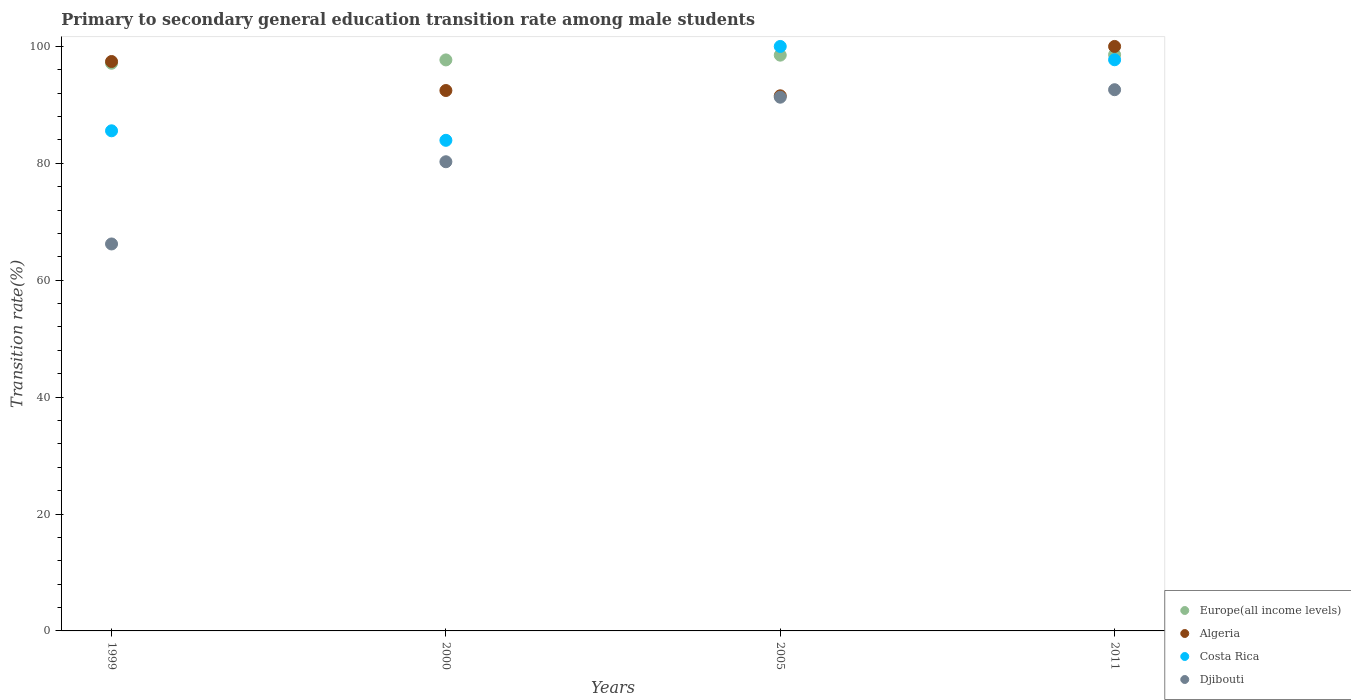What is the transition rate in Costa Rica in 2000?
Provide a succinct answer. 83.94. Across all years, what is the maximum transition rate in Algeria?
Offer a terse response. 100. Across all years, what is the minimum transition rate in Europe(all income levels)?
Your response must be concise. 97.13. What is the total transition rate in Algeria in the graph?
Ensure brevity in your answer.  381.44. What is the difference between the transition rate in Costa Rica in 1999 and that in 2011?
Make the answer very short. -12.15. What is the difference between the transition rate in Djibouti in 2011 and the transition rate in Costa Rica in 2000?
Offer a very short reply. 8.66. What is the average transition rate in Djibouti per year?
Your answer should be compact. 82.6. In the year 2005, what is the difference between the transition rate in Algeria and transition rate in Costa Rica?
Provide a succinct answer. -8.44. In how many years, is the transition rate in Algeria greater than 76 %?
Your answer should be very brief. 4. What is the ratio of the transition rate in Costa Rica in 2005 to that in 2011?
Your answer should be very brief. 1.02. What is the difference between the highest and the second highest transition rate in Costa Rica?
Your answer should be compact. 2.28. What is the difference between the highest and the lowest transition rate in Djibouti?
Give a very brief answer. 26.39. Is the sum of the transition rate in Costa Rica in 2005 and 2011 greater than the maximum transition rate in Algeria across all years?
Give a very brief answer. Yes. Is it the case that in every year, the sum of the transition rate in Costa Rica and transition rate in Algeria  is greater than the sum of transition rate in Europe(all income levels) and transition rate in Djibouti?
Ensure brevity in your answer.  No. Is it the case that in every year, the sum of the transition rate in Algeria and transition rate in Costa Rica  is greater than the transition rate in Djibouti?
Your answer should be very brief. Yes. Are the values on the major ticks of Y-axis written in scientific E-notation?
Provide a succinct answer. No. Does the graph contain any zero values?
Make the answer very short. No. Where does the legend appear in the graph?
Your answer should be very brief. Bottom right. What is the title of the graph?
Offer a very short reply. Primary to secondary general education transition rate among male students. What is the label or title of the Y-axis?
Your answer should be compact. Transition rate(%). What is the Transition rate(%) of Europe(all income levels) in 1999?
Your answer should be very brief. 97.13. What is the Transition rate(%) of Algeria in 1999?
Your answer should be very brief. 97.42. What is the Transition rate(%) in Costa Rica in 1999?
Make the answer very short. 85.57. What is the Transition rate(%) in Djibouti in 1999?
Your response must be concise. 66.21. What is the Transition rate(%) in Europe(all income levels) in 2000?
Your answer should be compact. 97.7. What is the Transition rate(%) in Algeria in 2000?
Keep it short and to the point. 92.46. What is the Transition rate(%) in Costa Rica in 2000?
Offer a terse response. 83.94. What is the Transition rate(%) in Djibouti in 2000?
Your answer should be very brief. 80.27. What is the Transition rate(%) in Europe(all income levels) in 2005?
Make the answer very short. 98.51. What is the Transition rate(%) of Algeria in 2005?
Offer a terse response. 91.56. What is the Transition rate(%) of Costa Rica in 2005?
Provide a succinct answer. 100. What is the Transition rate(%) in Djibouti in 2005?
Make the answer very short. 91.32. What is the Transition rate(%) of Europe(all income levels) in 2011?
Your answer should be compact. 98.59. What is the Transition rate(%) in Algeria in 2011?
Make the answer very short. 100. What is the Transition rate(%) of Costa Rica in 2011?
Offer a very short reply. 97.72. What is the Transition rate(%) of Djibouti in 2011?
Keep it short and to the point. 92.6. Across all years, what is the maximum Transition rate(%) in Europe(all income levels)?
Your answer should be compact. 98.59. Across all years, what is the maximum Transition rate(%) in Costa Rica?
Make the answer very short. 100. Across all years, what is the maximum Transition rate(%) in Djibouti?
Offer a terse response. 92.6. Across all years, what is the minimum Transition rate(%) in Europe(all income levels)?
Offer a very short reply. 97.13. Across all years, what is the minimum Transition rate(%) of Algeria?
Give a very brief answer. 91.56. Across all years, what is the minimum Transition rate(%) in Costa Rica?
Make the answer very short. 83.94. Across all years, what is the minimum Transition rate(%) in Djibouti?
Offer a terse response. 66.21. What is the total Transition rate(%) of Europe(all income levels) in the graph?
Provide a short and direct response. 391.92. What is the total Transition rate(%) of Algeria in the graph?
Your response must be concise. 381.44. What is the total Transition rate(%) of Costa Rica in the graph?
Make the answer very short. 367.23. What is the total Transition rate(%) of Djibouti in the graph?
Your answer should be very brief. 330.4. What is the difference between the Transition rate(%) of Europe(all income levels) in 1999 and that in 2000?
Your response must be concise. -0.57. What is the difference between the Transition rate(%) in Algeria in 1999 and that in 2000?
Your answer should be very brief. 4.96. What is the difference between the Transition rate(%) of Costa Rica in 1999 and that in 2000?
Your answer should be compact. 1.63. What is the difference between the Transition rate(%) in Djibouti in 1999 and that in 2000?
Give a very brief answer. -14.07. What is the difference between the Transition rate(%) of Europe(all income levels) in 1999 and that in 2005?
Provide a short and direct response. -1.39. What is the difference between the Transition rate(%) in Algeria in 1999 and that in 2005?
Your answer should be compact. 5.87. What is the difference between the Transition rate(%) in Costa Rica in 1999 and that in 2005?
Your answer should be compact. -14.43. What is the difference between the Transition rate(%) of Djibouti in 1999 and that in 2005?
Your answer should be very brief. -25.11. What is the difference between the Transition rate(%) in Europe(all income levels) in 1999 and that in 2011?
Your answer should be compact. -1.46. What is the difference between the Transition rate(%) of Algeria in 1999 and that in 2011?
Offer a terse response. -2.58. What is the difference between the Transition rate(%) of Costa Rica in 1999 and that in 2011?
Your answer should be very brief. -12.15. What is the difference between the Transition rate(%) in Djibouti in 1999 and that in 2011?
Offer a very short reply. -26.39. What is the difference between the Transition rate(%) in Europe(all income levels) in 2000 and that in 2005?
Offer a very short reply. -0.81. What is the difference between the Transition rate(%) in Algeria in 2000 and that in 2005?
Provide a succinct answer. 0.91. What is the difference between the Transition rate(%) in Costa Rica in 2000 and that in 2005?
Your answer should be compact. -16.06. What is the difference between the Transition rate(%) of Djibouti in 2000 and that in 2005?
Your answer should be compact. -11.04. What is the difference between the Transition rate(%) in Europe(all income levels) in 2000 and that in 2011?
Your answer should be very brief. -0.89. What is the difference between the Transition rate(%) in Algeria in 2000 and that in 2011?
Provide a short and direct response. -7.54. What is the difference between the Transition rate(%) in Costa Rica in 2000 and that in 2011?
Offer a very short reply. -13.78. What is the difference between the Transition rate(%) of Djibouti in 2000 and that in 2011?
Keep it short and to the point. -12.32. What is the difference between the Transition rate(%) of Europe(all income levels) in 2005 and that in 2011?
Offer a very short reply. -0.08. What is the difference between the Transition rate(%) in Algeria in 2005 and that in 2011?
Offer a terse response. -8.44. What is the difference between the Transition rate(%) in Costa Rica in 2005 and that in 2011?
Ensure brevity in your answer.  2.28. What is the difference between the Transition rate(%) in Djibouti in 2005 and that in 2011?
Provide a short and direct response. -1.28. What is the difference between the Transition rate(%) in Europe(all income levels) in 1999 and the Transition rate(%) in Algeria in 2000?
Your answer should be very brief. 4.66. What is the difference between the Transition rate(%) in Europe(all income levels) in 1999 and the Transition rate(%) in Costa Rica in 2000?
Your response must be concise. 13.19. What is the difference between the Transition rate(%) of Europe(all income levels) in 1999 and the Transition rate(%) of Djibouti in 2000?
Your response must be concise. 16.85. What is the difference between the Transition rate(%) in Algeria in 1999 and the Transition rate(%) in Costa Rica in 2000?
Your answer should be compact. 13.49. What is the difference between the Transition rate(%) in Algeria in 1999 and the Transition rate(%) in Djibouti in 2000?
Make the answer very short. 17.15. What is the difference between the Transition rate(%) in Costa Rica in 1999 and the Transition rate(%) in Djibouti in 2000?
Offer a very short reply. 5.3. What is the difference between the Transition rate(%) in Europe(all income levels) in 1999 and the Transition rate(%) in Algeria in 2005?
Ensure brevity in your answer.  5.57. What is the difference between the Transition rate(%) in Europe(all income levels) in 1999 and the Transition rate(%) in Costa Rica in 2005?
Make the answer very short. -2.87. What is the difference between the Transition rate(%) in Europe(all income levels) in 1999 and the Transition rate(%) in Djibouti in 2005?
Make the answer very short. 5.81. What is the difference between the Transition rate(%) in Algeria in 1999 and the Transition rate(%) in Costa Rica in 2005?
Offer a terse response. -2.58. What is the difference between the Transition rate(%) in Algeria in 1999 and the Transition rate(%) in Djibouti in 2005?
Offer a terse response. 6.11. What is the difference between the Transition rate(%) of Costa Rica in 1999 and the Transition rate(%) of Djibouti in 2005?
Your answer should be compact. -5.75. What is the difference between the Transition rate(%) in Europe(all income levels) in 1999 and the Transition rate(%) in Algeria in 2011?
Ensure brevity in your answer.  -2.87. What is the difference between the Transition rate(%) of Europe(all income levels) in 1999 and the Transition rate(%) of Costa Rica in 2011?
Provide a succinct answer. -0.6. What is the difference between the Transition rate(%) in Europe(all income levels) in 1999 and the Transition rate(%) in Djibouti in 2011?
Your answer should be compact. 4.53. What is the difference between the Transition rate(%) in Algeria in 1999 and the Transition rate(%) in Costa Rica in 2011?
Your answer should be very brief. -0.3. What is the difference between the Transition rate(%) in Algeria in 1999 and the Transition rate(%) in Djibouti in 2011?
Make the answer very short. 4.83. What is the difference between the Transition rate(%) of Costa Rica in 1999 and the Transition rate(%) of Djibouti in 2011?
Offer a terse response. -7.03. What is the difference between the Transition rate(%) in Europe(all income levels) in 2000 and the Transition rate(%) in Algeria in 2005?
Provide a short and direct response. 6.14. What is the difference between the Transition rate(%) of Europe(all income levels) in 2000 and the Transition rate(%) of Costa Rica in 2005?
Offer a terse response. -2.3. What is the difference between the Transition rate(%) in Europe(all income levels) in 2000 and the Transition rate(%) in Djibouti in 2005?
Ensure brevity in your answer.  6.38. What is the difference between the Transition rate(%) of Algeria in 2000 and the Transition rate(%) of Costa Rica in 2005?
Offer a very short reply. -7.54. What is the difference between the Transition rate(%) in Algeria in 2000 and the Transition rate(%) in Djibouti in 2005?
Give a very brief answer. 1.14. What is the difference between the Transition rate(%) in Costa Rica in 2000 and the Transition rate(%) in Djibouti in 2005?
Your answer should be very brief. -7.38. What is the difference between the Transition rate(%) in Europe(all income levels) in 2000 and the Transition rate(%) in Algeria in 2011?
Offer a terse response. -2.3. What is the difference between the Transition rate(%) of Europe(all income levels) in 2000 and the Transition rate(%) of Costa Rica in 2011?
Give a very brief answer. -0.02. What is the difference between the Transition rate(%) in Europe(all income levels) in 2000 and the Transition rate(%) in Djibouti in 2011?
Provide a short and direct response. 5.1. What is the difference between the Transition rate(%) of Algeria in 2000 and the Transition rate(%) of Costa Rica in 2011?
Your answer should be very brief. -5.26. What is the difference between the Transition rate(%) in Algeria in 2000 and the Transition rate(%) in Djibouti in 2011?
Offer a terse response. -0.14. What is the difference between the Transition rate(%) in Costa Rica in 2000 and the Transition rate(%) in Djibouti in 2011?
Offer a terse response. -8.66. What is the difference between the Transition rate(%) in Europe(all income levels) in 2005 and the Transition rate(%) in Algeria in 2011?
Your answer should be very brief. -1.49. What is the difference between the Transition rate(%) of Europe(all income levels) in 2005 and the Transition rate(%) of Costa Rica in 2011?
Offer a very short reply. 0.79. What is the difference between the Transition rate(%) in Europe(all income levels) in 2005 and the Transition rate(%) in Djibouti in 2011?
Give a very brief answer. 5.91. What is the difference between the Transition rate(%) in Algeria in 2005 and the Transition rate(%) in Costa Rica in 2011?
Provide a succinct answer. -6.17. What is the difference between the Transition rate(%) of Algeria in 2005 and the Transition rate(%) of Djibouti in 2011?
Make the answer very short. -1.04. What is the difference between the Transition rate(%) of Costa Rica in 2005 and the Transition rate(%) of Djibouti in 2011?
Provide a short and direct response. 7.4. What is the average Transition rate(%) of Europe(all income levels) per year?
Give a very brief answer. 97.98. What is the average Transition rate(%) in Algeria per year?
Your response must be concise. 95.36. What is the average Transition rate(%) in Costa Rica per year?
Your response must be concise. 91.81. What is the average Transition rate(%) in Djibouti per year?
Your response must be concise. 82.6. In the year 1999, what is the difference between the Transition rate(%) of Europe(all income levels) and Transition rate(%) of Algeria?
Make the answer very short. -0.3. In the year 1999, what is the difference between the Transition rate(%) of Europe(all income levels) and Transition rate(%) of Costa Rica?
Your answer should be very brief. 11.56. In the year 1999, what is the difference between the Transition rate(%) in Europe(all income levels) and Transition rate(%) in Djibouti?
Your response must be concise. 30.92. In the year 1999, what is the difference between the Transition rate(%) of Algeria and Transition rate(%) of Costa Rica?
Make the answer very short. 11.86. In the year 1999, what is the difference between the Transition rate(%) of Algeria and Transition rate(%) of Djibouti?
Give a very brief answer. 31.22. In the year 1999, what is the difference between the Transition rate(%) in Costa Rica and Transition rate(%) in Djibouti?
Provide a short and direct response. 19.36. In the year 2000, what is the difference between the Transition rate(%) of Europe(all income levels) and Transition rate(%) of Algeria?
Keep it short and to the point. 5.24. In the year 2000, what is the difference between the Transition rate(%) in Europe(all income levels) and Transition rate(%) in Costa Rica?
Offer a terse response. 13.76. In the year 2000, what is the difference between the Transition rate(%) in Europe(all income levels) and Transition rate(%) in Djibouti?
Your answer should be compact. 17.42. In the year 2000, what is the difference between the Transition rate(%) in Algeria and Transition rate(%) in Costa Rica?
Ensure brevity in your answer.  8.52. In the year 2000, what is the difference between the Transition rate(%) in Algeria and Transition rate(%) in Djibouti?
Ensure brevity in your answer.  12.19. In the year 2000, what is the difference between the Transition rate(%) in Costa Rica and Transition rate(%) in Djibouti?
Provide a succinct answer. 3.67. In the year 2005, what is the difference between the Transition rate(%) in Europe(all income levels) and Transition rate(%) in Algeria?
Provide a succinct answer. 6.96. In the year 2005, what is the difference between the Transition rate(%) in Europe(all income levels) and Transition rate(%) in Costa Rica?
Make the answer very short. -1.49. In the year 2005, what is the difference between the Transition rate(%) of Europe(all income levels) and Transition rate(%) of Djibouti?
Keep it short and to the point. 7.19. In the year 2005, what is the difference between the Transition rate(%) in Algeria and Transition rate(%) in Costa Rica?
Keep it short and to the point. -8.44. In the year 2005, what is the difference between the Transition rate(%) of Algeria and Transition rate(%) of Djibouti?
Provide a succinct answer. 0.24. In the year 2005, what is the difference between the Transition rate(%) in Costa Rica and Transition rate(%) in Djibouti?
Provide a short and direct response. 8.68. In the year 2011, what is the difference between the Transition rate(%) of Europe(all income levels) and Transition rate(%) of Algeria?
Your answer should be very brief. -1.41. In the year 2011, what is the difference between the Transition rate(%) of Europe(all income levels) and Transition rate(%) of Costa Rica?
Offer a terse response. 0.87. In the year 2011, what is the difference between the Transition rate(%) of Europe(all income levels) and Transition rate(%) of Djibouti?
Offer a very short reply. 5.99. In the year 2011, what is the difference between the Transition rate(%) in Algeria and Transition rate(%) in Costa Rica?
Provide a short and direct response. 2.28. In the year 2011, what is the difference between the Transition rate(%) in Algeria and Transition rate(%) in Djibouti?
Your answer should be compact. 7.4. In the year 2011, what is the difference between the Transition rate(%) of Costa Rica and Transition rate(%) of Djibouti?
Your answer should be very brief. 5.12. What is the ratio of the Transition rate(%) of Algeria in 1999 to that in 2000?
Give a very brief answer. 1.05. What is the ratio of the Transition rate(%) in Costa Rica in 1999 to that in 2000?
Provide a short and direct response. 1.02. What is the ratio of the Transition rate(%) of Djibouti in 1999 to that in 2000?
Keep it short and to the point. 0.82. What is the ratio of the Transition rate(%) of Europe(all income levels) in 1999 to that in 2005?
Make the answer very short. 0.99. What is the ratio of the Transition rate(%) in Algeria in 1999 to that in 2005?
Offer a very short reply. 1.06. What is the ratio of the Transition rate(%) in Costa Rica in 1999 to that in 2005?
Offer a terse response. 0.86. What is the ratio of the Transition rate(%) in Djibouti in 1999 to that in 2005?
Ensure brevity in your answer.  0.72. What is the ratio of the Transition rate(%) in Europe(all income levels) in 1999 to that in 2011?
Make the answer very short. 0.99. What is the ratio of the Transition rate(%) of Algeria in 1999 to that in 2011?
Ensure brevity in your answer.  0.97. What is the ratio of the Transition rate(%) of Costa Rica in 1999 to that in 2011?
Give a very brief answer. 0.88. What is the ratio of the Transition rate(%) of Djibouti in 1999 to that in 2011?
Offer a very short reply. 0.71. What is the ratio of the Transition rate(%) in Algeria in 2000 to that in 2005?
Offer a terse response. 1.01. What is the ratio of the Transition rate(%) in Costa Rica in 2000 to that in 2005?
Your response must be concise. 0.84. What is the ratio of the Transition rate(%) in Djibouti in 2000 to that in 2005?
Your answer should be very brief. 0.88. What is the ratio of the Transition rate(%) of Algeria in 2000 to that in 2011?
Offer a terse response. 0.92. What is the ratio of the Transition rate(%) in Costa Rica in 2000 to that in 2011?
Your response must be concise. 0.86. What is the ratio of the Transition rate(%) in Djibouti in 2000 to that in 2011?
Provide a succinct answer. 0.87. What is the ratio of the Transition rate(%) in Europe(all income levels) in 2005 to that in 2011?
Your answer should be very brief. 1. What is the ratio of the Transition rate(%) of Algeria in 2005 to that in 2011?
Make the answer very short. 0.92. What is the ratio of the Transition rate(%) of Costa Rica in 2005 to that in 2011?
Keep it short and to the point. 1.02. What is the ratio of the Transition rate(%) in Djibouti in 2005 to that in 2011?
Your answer should be very brief. 0.99. What is the difference between the highest and the second highest Transition rate(%) of Europe(all income levels)?
Your response must be concise. 0.08. What is the difference between the highest and the second highest Transition rate(%) of Algeria?
Make the answer very short. 2.58. What is the difference between the highest and the second highest Transition rate(%) in Costa Rica?
Offer a terse response. 2.28. What is the difference between the highest and the second highest Transition rate(%) of Djibouti?
Your response must be concise. 1.28. What is the difference between the highest and the lowest Transition rate(%) in Europe(all income levels)?
Provide a succinct answer. 1.46. What is the difference between the highest and the lowest Transition rate(%) of Algeria?
Your response must be concise. 8.44. What is the difference between the highest and the lowest Transition rate(%) in Costa Rica?
Your answer should be compact. 16.06. What is the difference between the highest and the lowest Transition rate(%) in Djibouti?
Make the answer very short. 26.39. 